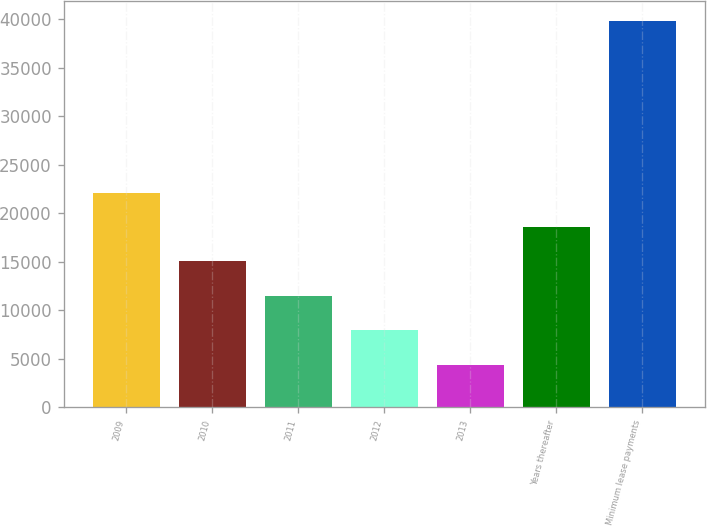Convert chart. <chart><loc_0><loc_0><loc_500><loc_500><bar_chart><fcel>2009<fcel>2010<fcel>2011<fcel>2012<fcel>2013<fcel>Years thereafter<fcel>Minimum lease payments<nl><fcel>22136.5<fcel>15042.7<fcel>11495.8<fcel>7948.9<fcel>4402<fcel>18589.6<fcel>39871<nl></chart> 